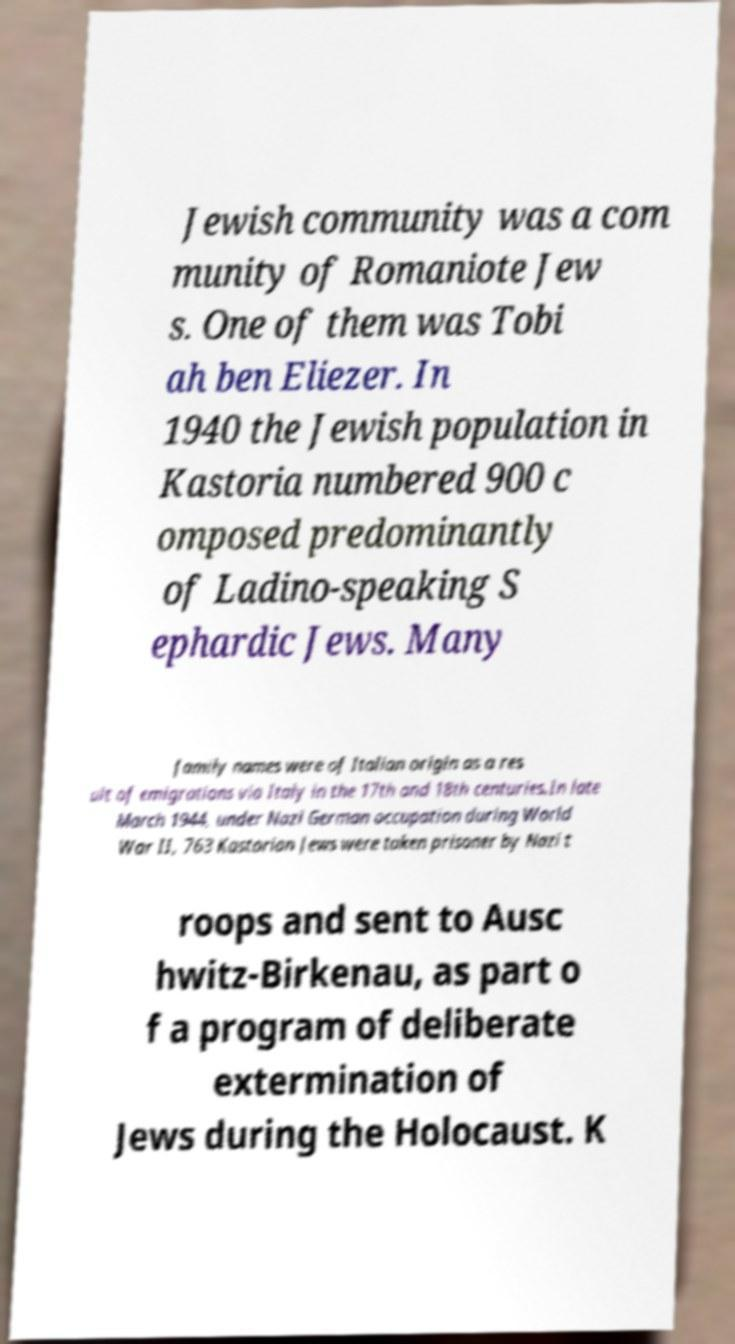Please identify and transcribe the text found in this image. Jewish community was a com munity of Romaniote Jew s. One of them was Tobi ah ben Eliezer. In 1940 the Jewish population in Kastoria numbered 900 c omposed predominantly of Ladino-speaking S ephardic Jews. Many family names were of Italian origin as a res ult of emigrations via Italy in the 17th and 18th centuries.In late March 1944, under Nazi German occupation during World War II, 763 Kastorian Jews were taken prisoner by Nazi t roops and sent to Ausc hwitz-Birkenau, as part o f a program of deliberate extermination of Jews during the Holocaust. K 